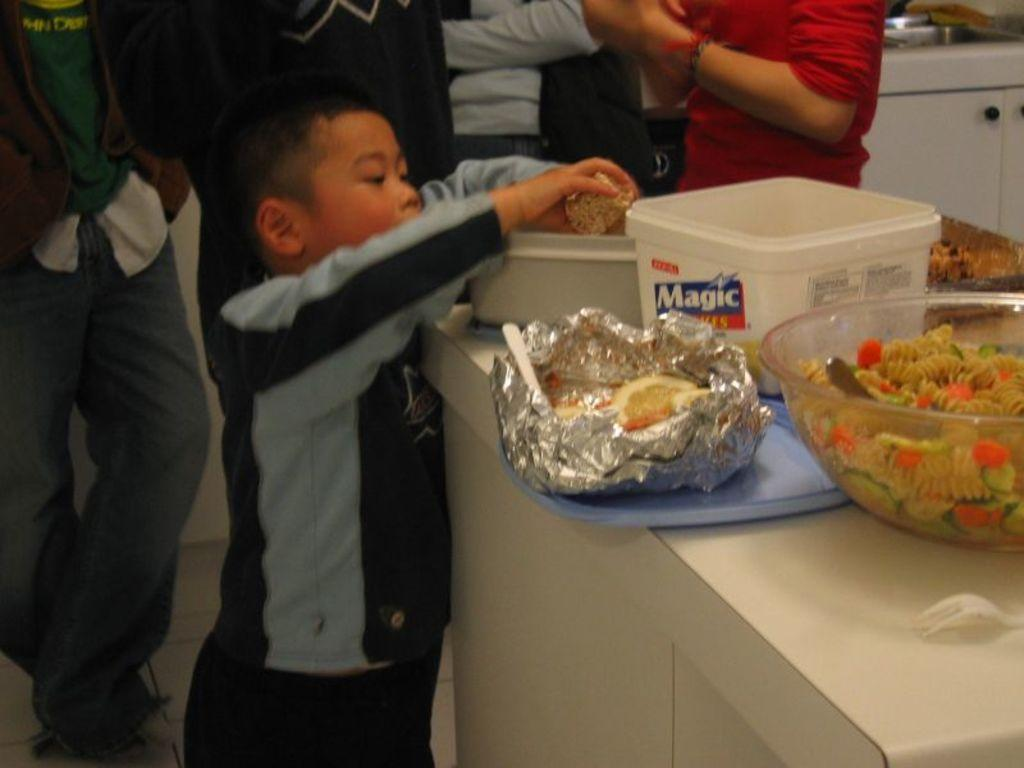What can be seen in the image involving people? There are people standing in the image. Where is the table located in the image? The table is in the bottom right side of the image. What items are on the table? There are bowls, spoons, and food on the table. What type of blade is being used to cut the food on the table? There is no blade visible in the image; only bowls, spoons, and food are present on the table. 